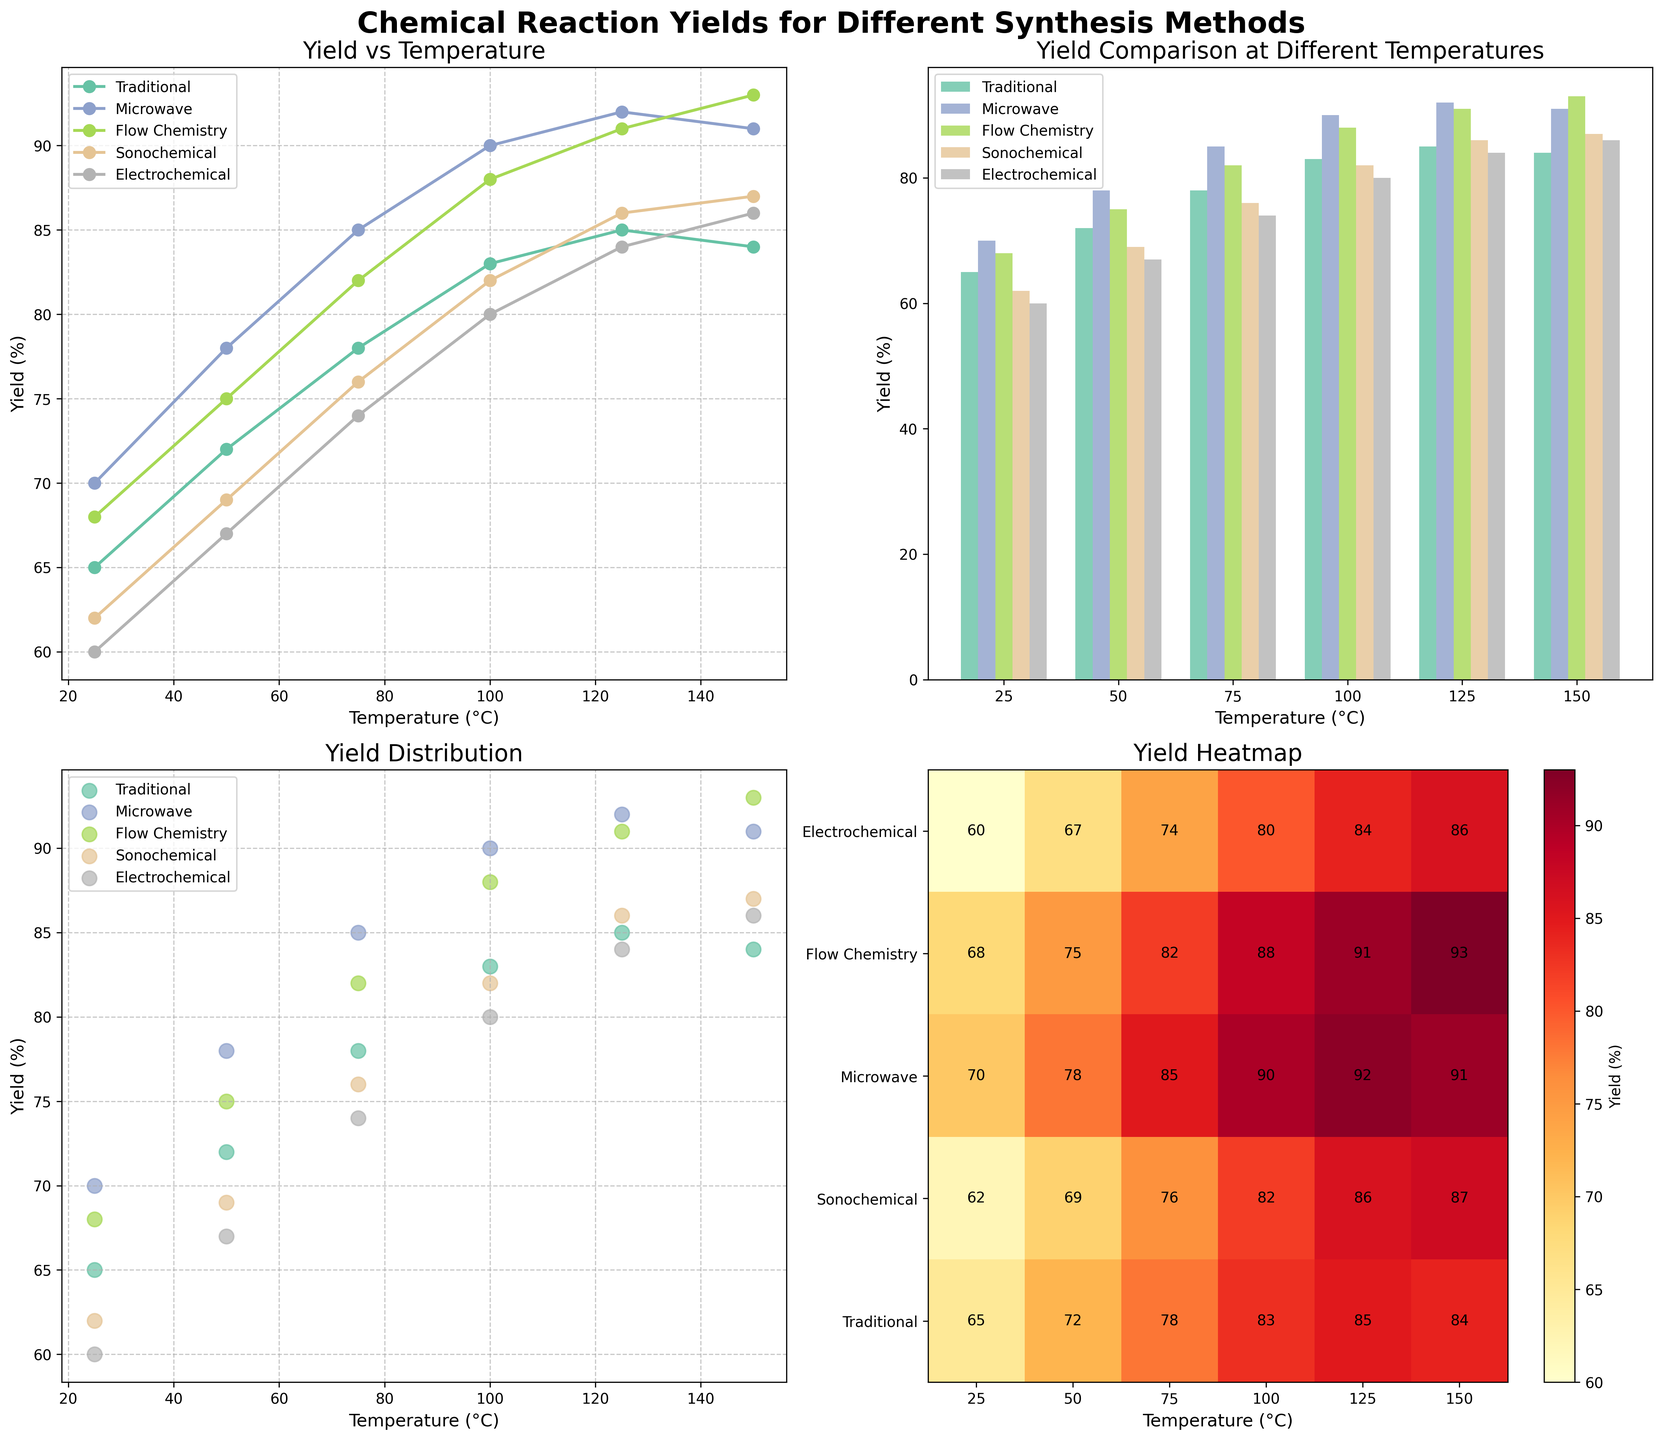What is the overall trend of the yield for the Traditional method as the temperature increases? Observing the line plot for the Traditional method, the yield increases consistently as the temperature increases from 25°C to 125°C, peaking at 85%. At 150°C, the yield slightly decreases to 84%.
Answer: Increasing trend with a slight dip at 150°C Which method has the highest yield at 100°C? From the line plot, bar plot, and scatter plot, we see that the Microwave method reaches the highest yield at 100°C with a yield of 90%.
Answer: Microwave Compare the yields of Flow Chemistry and Sonochemical methods at 125°C. Which one is higher and by how much? From the bar plot and the heat map, the yield of Flow Chemistry at 125°C is 91% and for Sonochemical it is 86%. The difference is 91% - 86% = 5%.
Answer: Flow Chemistry by 5% Based on the scatter plot, which method shows the greatest consistency in yield across different temperatures? Observing the spread of data points in the scatter plot, the Microwave method shows the most consistent yields as there is a minimal change in yield between different temperatures.
Answer: Microwave Calculate the average yield for the Electrochemical method across all temperatures. Sum of Electrochemical yields: 60 + 67 + 74 + 80 + 84 + 86 = 451. Number of temperature points: 6. Average yield = 451 / 6 = 75.17%.
Answer: 75.17% Which synthesis method achieves the highest overall yield and at what temperature? Referring to all the subplots, the Flow Chemistry method achieves the highest overall yield at 150°C with a yield of 93%.
Answer: Flow Chemistry at 150°C What color represents the Microwave method in the visualizations, and does this method achieve a higher yield than the Traditional method at 50°C? The Microwave method is represented by a specific color (such as orange or green depending on the visualization standards). At 50°C, Microwave (78%) achieves a higher yield than the Traditional method (72%).
Answer: Yes, Microwave is higher Which method has the steepest increase in yield between 25°C and 75°C? Observing the line plot, the Microwave method shows the steepest increase between 25°C (70%) and 75°C (85%), an increase of 15 percentage points.
Answer: Microwave What is the variance in yield for the Sonochemical method across all temperatures? Calculate the variance by noting the yields for Sonochemical (62, 69, 76, 82, 86, 87), calculating the mean (77), and then finding the average of the squared differences from the mean. Variance: [(62-77)² + (69-77)² + (76-77)² + (82-77)² + (86-77)² + (87-77)²] / 6 = 64.67.
Answer: 64.67 